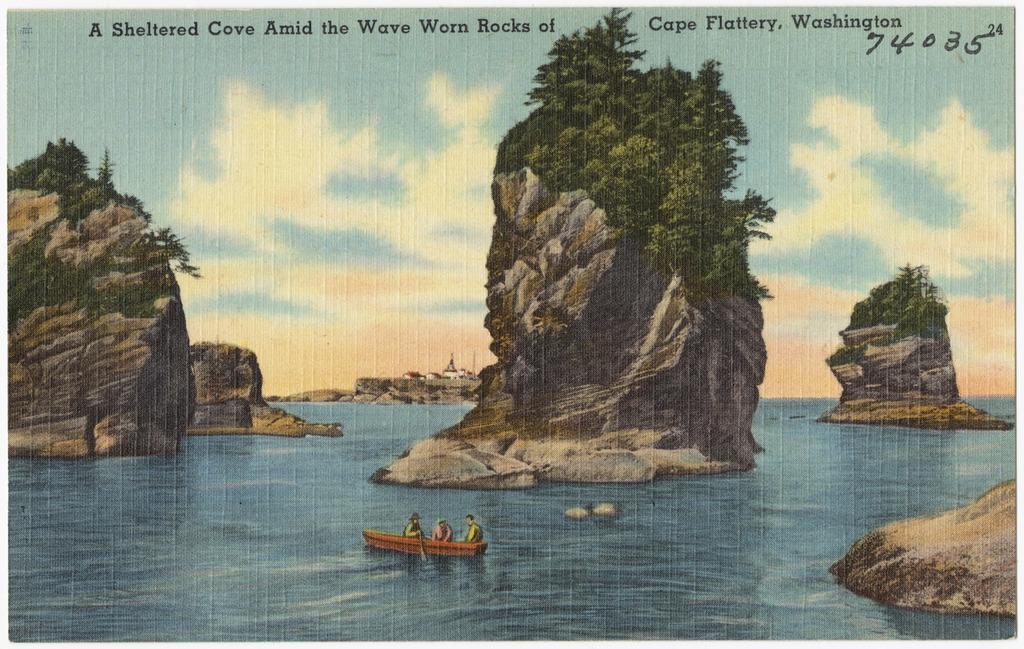In one or two sentences, can you explain what this image depicts? It is a poster. In this image, we can see rocks, trees. At the bottom, we can see few people are sailing a boat on the water. Background there is a sky. 